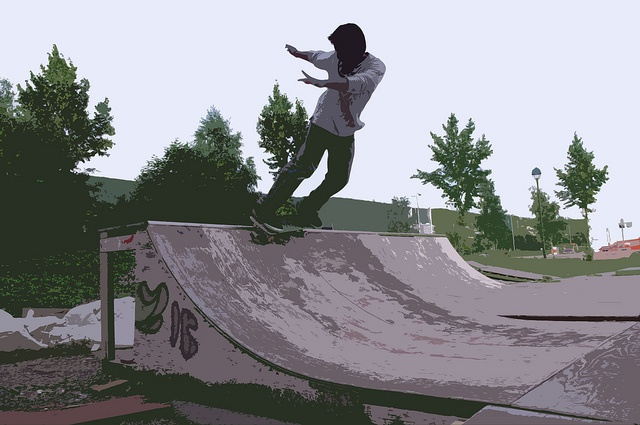Describe the objects in this image and their specific colors. I can see people in lavender, black, and gray tones and skateboard in lavender, black, gray, and darkgray tones in this image. 